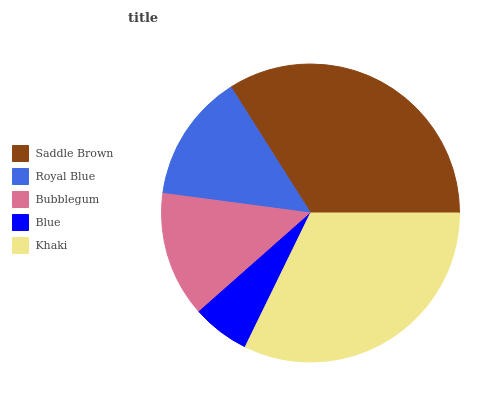Is Blue the minimum?
Answer yes or no. Yes. Is Saddle Brown the maximum?
Answer yes or no. Yes. Is Royal Blue the minimum?
Answer yes or no. No. Is Royal Blue the maximum?
Answer yes or no. No. Is Saddle Brown greater than Royal Blue?
Answer yes or no. Yes. Is Royal Blue less than Saddle Brown?
Answer yes or no. Yes. Is Royal Blue greater than Saddle Brown?
Answer yes or no. No. Is Saddle Brown less than Royal Blue?
Answer yes or no. No. Is Royal Blue the high median?
Answer yes or no. Yes. Is Royal Blue the low median?
Answer yes or no. Yes. Is Bubblegum the high median?
Answer yes or no. No. Is Khaki the low median?
Answer yes or no. No. 